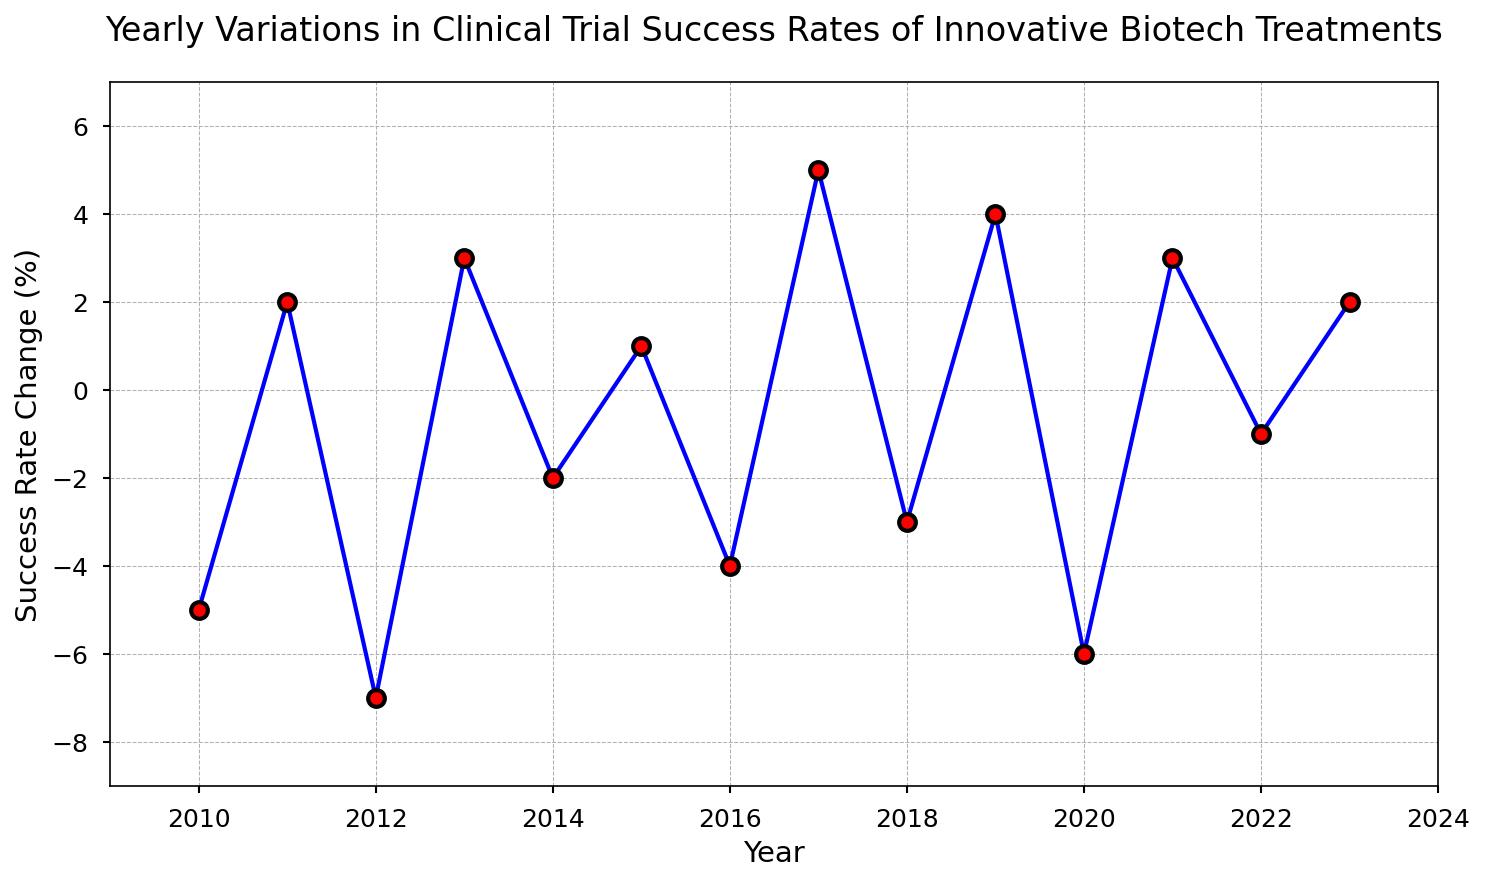What is the overall trend in clinical trial success rates from 2010 to 2023? By examining the line chart, we see that the success rate changes fluctuate significantly. There are both positive and negative changes, indicating a lack of a clear upward or downward trend over the period.
Answer: No clear trend During which years did the success rate change positively? By looking at the chart, we identify the years with positive changes: 2011, 2013, 2015, 2017, 2019, 2021, and 2023.
Answer: 2011, 2013, 2015, 2017, 2019, 2021, 2023 What was the maximum decline in success rate, and in which year did it occur? Observing the lowest points on the chart, we see that the largest decline was a decrease of 7% in 2012.
Answer: 2012, -7% Compare the success rates between 2010 and 2023. Which year had a higher rate? In 2010 there was a -5% change, and in 2023 there was a +2% change. Therefore, 2023 had a higher success rate.
Answer: 2023 What were the changes in success rates in 2019 and 2020, and how do they compare? From the chart, 2019 had a +4% change, and 2020 had a -6% change. Comparing them, 2020 was lower by 10 percentage points.
Answer: 2019: +4%, 2020: -6%, 2020 is lower What is the average success rate change over the period from 2010 to 2023? To find this, sum the changes: -5 + 2 - 7 + 3 - 2 + 1 - 4 + 5 - 3 + 4 - 6 + 3 - 1 + 2 = -8, then divide by 14 years: -8/14 ≈ -0.57%.
Answer: -0.57% How did the success rate change in the year following the highest positive change? The highest positive change was +5% in 2017. The following year, 2018, had a -3% change.
Answer: -3% What is the sum of success rate changes from 2015 to 2018? Sum the changes for these years: 1 + (-4) + 5 + (-3) = -1.
Answer: -1 Identify the years with a negative change and calculate their average change. Affected years: 2010, 2012, 2014, 2016, 2018, 2020, 2022. Sum: -5 - 7 - 2 - 4 - 3 - 6 - 1 = -28. Average: -28 / 7 ≈ -4%.
Answer: -4% Was there any year with no change in success rate? Checking each data point on the chart, every year shows a non-zero change, either positive or negative.
Answer: No 